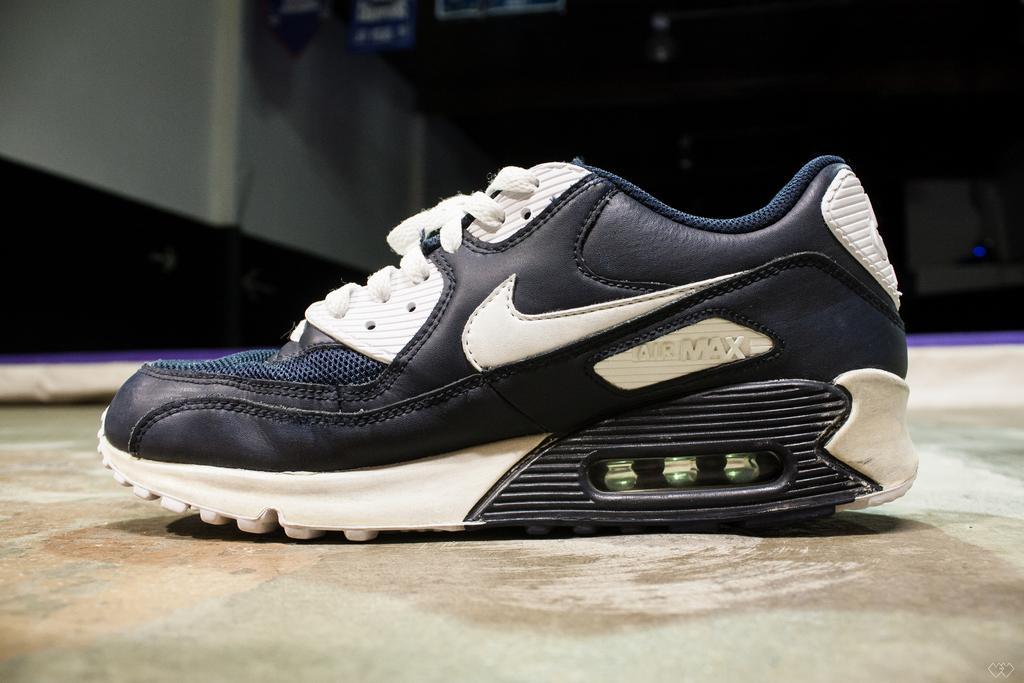Describe this image in one or two sentences. In this image we can see a shoe placed on the floor. 